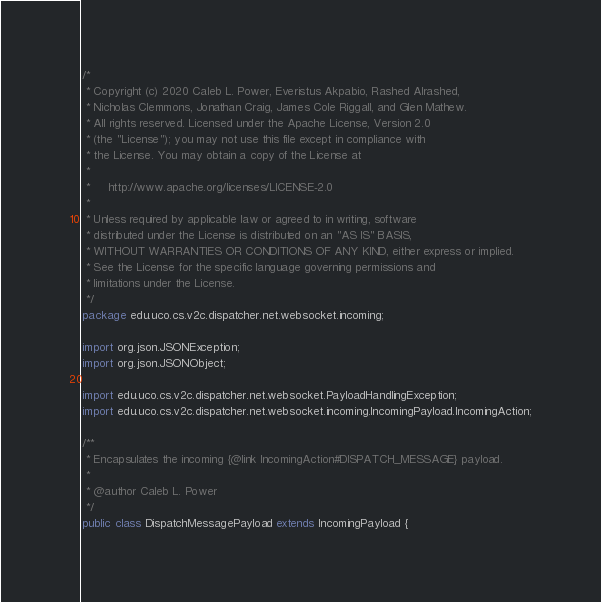<code> <loc_0><loc_0><loc_500><loc_500><_Java_>/*
 * Copyright (c) 2020 Caleb L. Power, Everistus Akpabio, Rashed Alrashed,
 * Nicholas Clemmons, Jonathan Craig, James Cole Riggall, and Glen Mathew.
 * All rights reserved. Licensed under the Apache License, Version 2.0
 * (the "License"); you may not use this file except in compliance with
 * the License. You may obtain a copy of the License at
 * 
 *     http://www.apache.org/licenses/LICENSE-2.0
 * 
 * Unless required by applicable law or agreed to in writing, software
 * distributed under the License is distributed on an "AS IS" BASIS,
 * WITHOUT WARRANTIES OR CONDITIONS OF ANY KIND, either express or implied.
 * See the License for the specific language governing permissions and
 * limitations under the License.
 */
package edu.uco.cs.v2c.dispatcher.net.websocket.incoming;

import org.json.JSONException;
import org.json.JSONObject;

import edu.uco.cs.v2c.dispatcher.net.websocket.PayloadHandlingException;
import edu.uco.cs.v2c.dispatcher.net.websocket.incoming.IncomingPayload.IncomingAction;

/**
 * Encapsulates the incoming {@link IncomingAction#DISPATCH_MESSAGE} payload.
 * 
 * @author Caleb L. Power
 */
public class DispatchMessagePayload extends IncomingPayload {</code> 